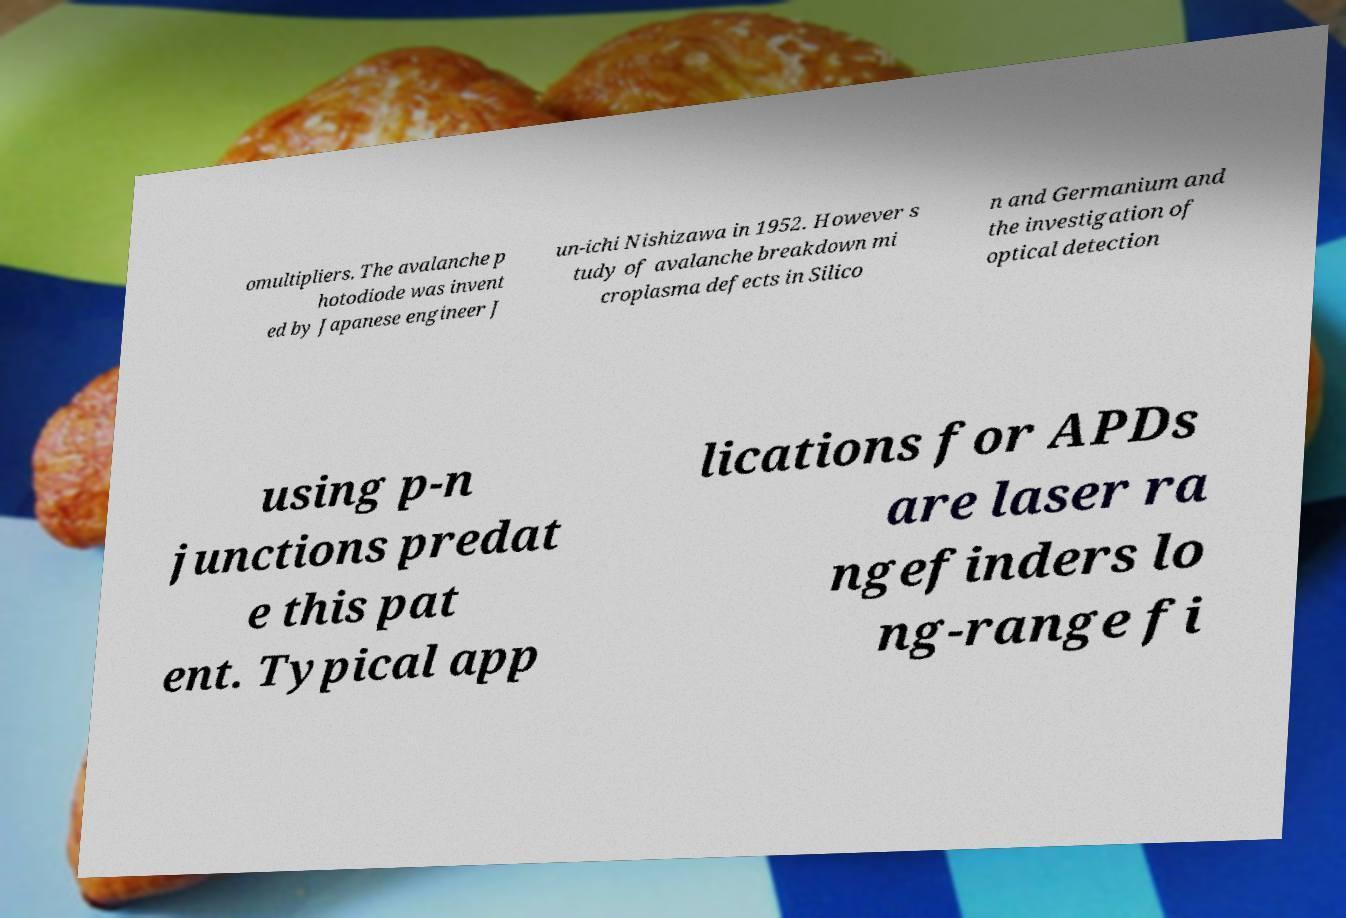Can you accurately transcribe the text from the provided image for me? omultipliers. The avalanche p hotodiode was invent ed by Japanese engineer J un-ichi Nishizawa in 1952. However s tudy of avalanche breakdown mi croplasma defects in Silico n and Germanium and the investigation of optical detection using p-n junctions predat e this pat ent. Typical app lications for APDs are laser ra ngefinders lo ng-range fi 